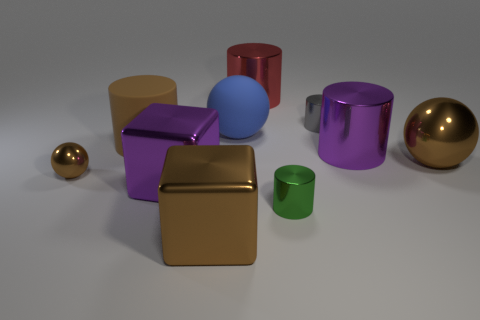What number of big red things have the same material as the tiny gray cylinder?
Your answer should be compact. 1. What number of objects are either big metallic cubes or purple objects?
Your answer should be compact. 3. Are there any matte cylinders that are in front of the small shiny thing that is left of the small green metal object?
Provide a succinct answer. No. Are there more gray metallic things that are in front of the red cylinder than large blue spheres that are right of the blue rubber sphere?
Ensure brevity in your answer.  Yes. What material is the cube that is the same color as the small metallic ball?
Your answer should be very brief. Metal. How many cylinders are the same color as the tiny sphere?
Your answer should be compact. 1. There is a large matte object that is right of the brown rubber object; does it have the same color as the small object right of the green metallic cylinder?
Make the answer very short. No. There is a gray metal cylinder; are there any tiny brown metallic balls in front of it?
Your answer should be very brief. Yes. What is the material of the large blue ball?
Your answer should be very brief. Rubber. What is the shape of the purple metal object that is to the left of the red thing?
Ensure brevity in your answer.  Cube. 